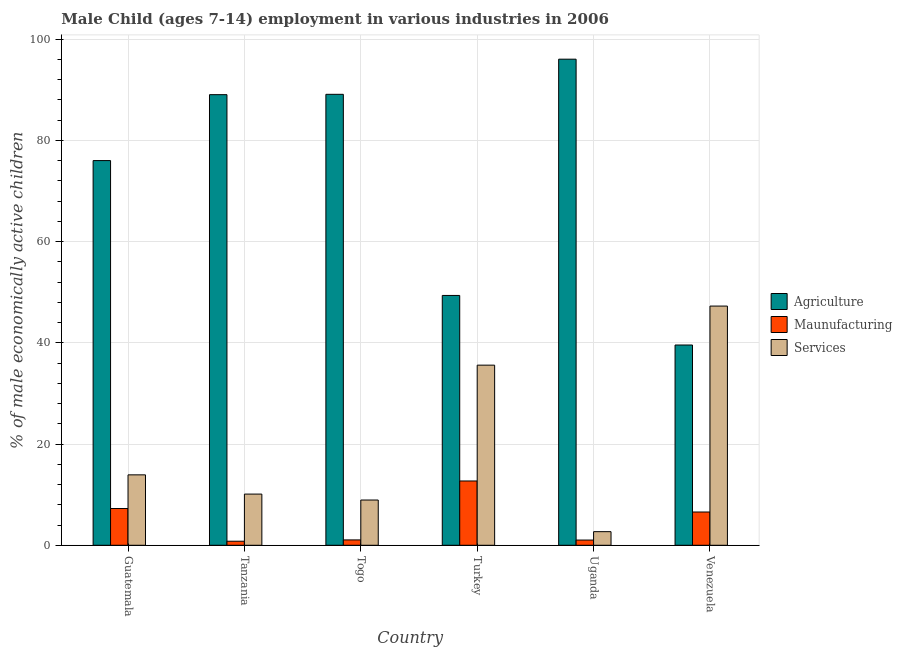Are the number of bars on each tick of the X-axis equal?
Offer a very short reply. Yes. How many bars are there on the 5th tick from the right?
Your response must be concise. 3. What is the label of the 3rd group of bars from the left?
Offer a terse response. Togo. In how many cases, is the number of bars for a given country not equal to the number of legend labels?
Provide a short and direct response. 0. What is the percentage of economically active children in services in Uganda?
Your answer should be very brief. 2.69. Across all countries, what is the maximum percentage of economically active children in manufacturing?
Make the answer very short. 12.7. Across all countries, what is the minimum percentage of economically active children in agriculture?
Offer a very short reply. 39.56. In which country was the percentage of economically active children in services maximum?
Provide a short and direct response. Venezuela. In which country was the percentage of economically active children in services minimum?
Give a very brief answer. Uganda. What is the total percentage of economically active children in manufacturing in the graph?
Provide a short and direct response. 29.42. What is the difference between the percentage of economically active children in manufacturing in Tanzania and that in Venezuela?
Provide a short and direct response. -5.77. What is the difference between the percentage of economically active children in services in Tanzania and the percentage of economically active children in agriculture in Turkey?
Give a very brief answer. -39.24. What is the average percentage of economically active children in agriculture per country?
Ensure brevity in your answer.  73.17. What is the difference between the percentage of economically active children in services and percentage of economically active children in agriculture in Turkey?
Give a very brief answer. -13.77. In how many countries, is the percentage of economically active children in services greater than 36 %?
Your answer should be very brief. 1. What is the ratio of the percentage of economically active children in agriculture in Tanzania to that in Uganda?
Ensure brevity in your answer.  0.93. Is the percentage of economically active children in services in Uganda less than that in Venezuela?
Offer a terse response. Yes. Is the difference between the percentage of economically active children in agriculture in Togo and Uganda greater than the difference between the percentage of economically active children in manufacturing in Togo and Uganda?
Your answer should be compact. No. What is the difference between the highest and the second highest percentage of economically active children in services?
Provide a short and direct response. 11.67. What is the difference between the highest and the lowest percentage of economically active children in agriculture?
Keep it short and to the point. 56.46. In how many countries, is the percentage of economically active children in services greater than the average percentage of economically active children in services taken over all countries?
Keep it short and to the point. 2. What does the 3rd bar from the left in Tanzania represents?
Offer a terse response. Services. What does the 1st bar from the right in Togo represents?
Keep it short and to the point. Services. Are all the bars in the graph horizontal?
Offer a very short reply. No. How many countries are there in the graph?
Keep it short and to the point. 6. What is the difference between two consecutive major ticks on the Y-axis?
Your answer should be very brief. 20. Does the graph contain any zero values?
Provide a short and direct response. No. What is the title of the graph?
Your answer should be compact. Male Child (ages 7-14) employment in various industries in 2006. Does "Ages 0-14" appear as one of the legend labels in the graph?
Offer a very short reply. No. What is the label or title of the Y-axis?
Your answer should be compact. % of male economically active children. What is the % of male economically active children in Agriculture in Guatemala?
Offer a very short reply. 75.99. What is the % of male economically active children of Maunufacturing in Guatemala?
Your answer should be very brief. 7.26. What is the % of male economically active children of Services in Guatemala?
Ensure brevity in your answer.  13.91. What is the % of male economically active children of Agriculture in Tanzania?
Keep it short and to the point. 89.01. What is the % of male economically active children in Maunufacturing in Tanzania?
Provide a short and direct response. 0.8. What is the % of male economically active children in Services in Tanzania?
Give a very brief answer. 10.11. What is the % of male economically active children in Agriculture in Togo?
Provide a short and direct response. 89.08. What is the % of male economically active children of Maunufacturing in Togo?
Offer a terse response. 1.06. What is the % of male economically active children in Services in Togo?
Your response must be concise. 8.94. What is the % of male economically active children of Agriculture in Turkey?
Your answer should be very brief. 49.35. What is the % of male economically active children in Maunufacturing in Turkey?
Offer a very short reply. 12.7. What is the % of male economically active children in Services in Turkey?
Your answer should be very brief. 35.58. What is the % of male economically active children in Agriculture in Uganda?
Provide a succinct answer. 96.02. What is the % of male economically active children in Services in Uganda?
Offer a terse response. 2.69. What is the % of male economically active children of Agriculture in Venezuela?
Offer a very short reply. 39.56. What is the % of male economically active children of Maunufacturing in Venezuela?
Make the answer very short. 6.57. What is the % of male economically active children of Services in Venezuela?
Your answer should be very brief. 47.25. Across all countries, what is the maximum % of male economically active children in Agriculture?
Offer a very short reply. 96.02. Across all countries, what is the maximum % of male economically active children of Services?
Keep it short and to the point. 47.25. Across all countries, what is the minimum % of male economically active children of Agriculture?
Offer a very short reply. 39.56. Across all countries, what is the minimum % of male economically active children in Services?
Offer a very short reply. 2.69. What is the total % of male economically active children in Agriculture in the graph?
Your answer should be very brief. 439.01. What is the total % of male economically active children of Maunufacturing in the graph?
Offer a terse response. 29.42. What is the total % of male economically active children in Services in the graph?
Offer a terse response. 118.48. What is the difference between the % of male economically active children in Agriculture in Guatemala and that in Tanzania?
Ensure brevity in your answer.  -13.02. What is the difference between the % of male economically active children of Maunufacturing in Guatemala and that in Tanzania?
Your answer should be compact. 6.46. What is the difference between the % of male economically active children of Services in Guatemala and that in Tanzania?
Your answer should be very brief. 3.8. What is the difference between the % of male economically active children of Agriculture in Guatemala and that in Togo?
Ensure brevity in your answer.  -13.09. What is the difference between the % of male economically active children in Maunufacturing in Guatemala and that in Togo?
Make the answer very short. 6.2. What is the difference between the % of male economically active children in Services in Guatemala and that in Togo?
Give a very brief answer. 4.97. What is the difference between the % of male economically active children of Agriculture in Guatemala and that in Turkey?
Keep it short and to the point. 26.64. What is the difference between the % of male economically active children of Maunufacturing in Guatemala and that in Turkey?
Make the answer very short. -5.44. What is the difference between the % of male economically active children in Services in Guatemala and that in Turkey?
Your answer should be compact. -21.67. What is the difference between the % of male economically active children of Agriculture in Guatemala and that in Uganda?
Your answer should be compact. -20.03. What is the difference between the % of male economically active children in Maunufacturing in Guatemala and that in Uganda?
Offer a very short reply. 6.23. What is the difference between the % of male economically active children of Services in Guatemala and that in Uganda?
Keep it short and to the point. 11.22. What is the difference between the % of male economically active children of Agriculture in Guatemala and that in Venezuela?
Offer a very short reply. 36.43. What is the difference between the % of male economically active children of Maunufacturing in Guatemala and that in Venezuela?
Provide a short and direct response. 0.69. What is the difference between the % of male economically active children in Services in Guatemala and that in Venezuela?
Make the answer very short. -33.34. What is the difference between the % of male economically active children of Agriculture in Tanzania and that in Togo?
Make the answer very short. -0.07. What is the difference between the % of male economically active children of Maunufacturing in Tanzania and that in Togo?
Your answer should be very brief. -0.26. What is the difference between the % of male economically active children in Services in Tanzania and that in Togo?
Make the answer very short. 1.17. What is the difference between the % of male economically active children in Agriculture in Tanzania and that in Turkey?
Offer a very short reply. 39.66. What is the difference between the % of male economically active children of Maunufacturing in Tanzania and that in Turkey?
Your response must be concise. -11.9. What is the difference between the % of male economically active children in Services in Tanzania and that in Turkey?
Offer a very short reply. -25.47. What is the difference between the % of male economically active children of Agriculture in Tanzania and that in Uganda?
Ensure brevity in your answer.  -7.01. What is the difference between the % of male economically active children of Maunufacturing in Tanzania and that in Uganda?
Provide a short and direct response. -0.23. What is the difference between the % of male economically active children of Services in Tanzania and that in Uganda?
Make the answer very short. 7.42. What is the difference between the % of male economically active children of Agriculture in Tanzania and that in Venezuela?
Offer a very short reply. 49.45. What is the difference between the % of male economically active children in Maunufacturing in Tanzania and that in Venezuela?
Offer a terse response. -5.77. What is the difference between the % of male economically active children of Services in Tanzania and that in Venezuela?
Offer a terse response. -37.14. What is the difference between the % of male economically active children in Agriculture in Togo and that in Turkey?
Your answer should be very brief. 39.73. What is the difference between the % of male economically active children of Maunufacturing in Togo and that in Turkey?
Provide a succinct answer. -11.64. What is the difference between the % of male economically active children of Services in Togo and that in Turkey?
Your answer should be very brief. -26.64. What is the difference between the % of male economically active children in Agriculture in Togo and that in Uganda?
Provide a succinct answer. -6.94. What is the difference between the % of male economically active children of Services in Togo and that in Uganda?
Your answer should be very brief. 6.25. What is the difference between the % of male economically active children in Agriculture in Togo and that in Venezuela?
Your answer should be compact. 49.52. What is the difference between the % of male economically active children in Maunufacturing in Togo and that in Venezuela?
Offer a terse response. -5.51. What is the difference between the % of male economically active children of Services in Togo and that in Venezuela?
Offer a terse response. -38.31. What is the difference between the % of male economically active children in Agriculture in Turkey and that in Uganda?
Your answer should be compact. -46.67. What is the difference between the % of male economically active children in Maunufacturing in Turkey and that in Uganda?
Give a very brief answer. 11.67. What is the difference between the % of male economically active children in Services in Turkey and that in Uganda?
Give a very brief answer. 32.89. What is the difference between the % of male economically active children in Agriculture in Turkey and that in Venezuela?
Ensure brevity in your answer.  9.79. What is the difference between the % of male economically active children of Maunufacturing in Turkey and that in Venezuela?
Provide a succinct answer. 6.13. What is the difference between the % of male economically active children in Services in Turkey and that in Venezuela?
Ensure brevity in your answer.  -11.67. What is the difference between the % of male economically active children of Agriculture in Uganda and that in Venezuela?
Provide a short and direct response. 56.46. What is the difference between the % of male economically active children in Maunufacturing in Uganda and that in Venezuela?
Offer a terse response. -5.54. What is the difference between the % of male economically active children in Services in Uganda and that in Venezuela?
Keep it short and to the point. -44.56. What is the difference between the % of male economically active children of Agriculture in Guatemala and the % of male economically active children of Maunufacturing in Tanzania?
Give a very brief answer. 75.19. What is the difference between the % of male economically active children in Agriculture in Guatemala and the % of male economically active children in Services in Tanzania?
Make the answer very short. 65.88. What is the difference between the % of male economically active children in Maunufacturing in Guatemala and the % of male economically active children in Services in Tanzania?
Your response must be concise. -2.85. What is the difference between the % of male economically active children of Agriculture in Guatemala and the % of male economically active children of Maunufacturing in Togo?
Ensure brevity in your answer.  74.93. What is the difference between the % of male economically active children of Agriculture in Guatemala and the % of male economically active children of Services in Togo?
Provide a short and direct response. 67.05. What is the difference between the % of male economically active children in Maunufacturing in Guatemala and the % of male economically active children in Services in Togo?
Provide a short and direct response. -1.68. What is the difference between the % of male economically active children of Agriculture in Guatemala and the % of male economically active children of Maunufacturing in Turkey?
Offer a terse response. 63.29. What is the difference between the % of male economically active children of Agriculture in Guatemala and the % of male economically active children of Services in Turkey?
Provide a short and direct response. 40.41. What is the difference between the % of male economically active children in Maunufacturing in Guatemala and the % of male economically active children in Services in Turkey?
Your response must be concise. -28.32. What is the difference between the % of male economically active children in Agriculture in Guatemala and the % of male economically active children in Maunufacturing in Uganda?
Provide a short and direct response. 74.96. What is the difference between the % of male economically active children of Agriculture in Guatemala and the % of male economically active children of Services in Uganda?
Offer a very short reply. 73.3. What is the difference between the % of male economically active children in Maunufacturing in Guatemala and the % of male economically active children in Services in Uganda?
Give a very brief answer. 4.57. What is the difference between the % of male economically active children of Agriculture in Guatemala and the % of male economically active children of Maunufacturing in Venezuela?
Provide a short and direct response. 69.42. What is the difference between the % of male economically active children of Agriculture in Guatemala and the % of male economically active children of Services in Venezuela?
Your response must be concise. 28.74. What is the difference between the % of male economically active children of Maunufacturing in Guatemala and the % of male economically active children of Services in Venezuela?
Keep it short and to the point. -39.99. What is the difference between the % of male economically active children in Agriculture in Tanzania and the % of male economically active children in Maunufacturing in Togo?
Make the answer very short. 87.95. What is the difference between the % of male economically active children in Agriculture in Tanzania and the % of male economically active children in Services in Togo?
Provide a short and direct response. 80.07. What is the difference between the % of male economically active children of Maunufacturing in Tanzania and the % of male economically active children of Services in Togo?
Your answer should be compact. -8.14. What is the difference between the % of male economically active children of Agriculture in Tanzania and the % of male economically active children of Maunufacturing in Turkey?
Ensure brevity in your answer.  76.31. What is the difference between the % of male economically active children in Agriculture in Tanzania and the % of male economically active children in Services in Turkey?
Give a very brief answer. 53.43. What is the difference between the % of male economically active children in Maunufacturing in Tanzania and the % of male economically active children in Services in Turkey?
Keep it short and to the point. -34.78. What is the difference between the % of male economically active children of Agriculture in Tanzania and the % of male economically active children of Maunufacturing in Uganda?
Offer a very short reply. 87.98. What is the difference between the % of male economically active children in Agriculture in Tanzania and the % of male economically active children in Services in Uganda?
Give a very brief answer. 86.32. What is the difference between the % of male economically active children of Maunufacturing in Tanzania and the % of male economically active children of Services in Uganda?
Offer a very short reply. -1.89. What is the difference between the % of male economically active children of Agriculture in Tanzania and the % of male economically active children of Maunufacturing in Venezuela?
Give a very brief answer. 82.44. What is the difference between the % of male economically active children of Agriculture in Tanzania and the % of male economically active children of Services in Venezuela?
Offer a terse response. 41.76. What is the difference between the % of male economically active children of Maunufacturing in Tanzania and the % of male economically active children of Services in Venezuela?
Give a very brief answer. -46.45. What is the difference between the % of male economically active children of Agriculture in Togo and the % of male economically active children of Maunufacturing in Turkey?
Your response must be concise. 76.38. What is the difference between the % of male economically active children of Agriculture in Togo and the % of male economically active children of Services in Turkey?
Offer a very short reply. 53.5. What is the difference between the % of male economically active children of Maunufacturing in Togo and the % of male economically active children of Services in Turkey?
Make the answer very short. -34.52. What is the difference between the % of male economically active children in Agriculture in Togo and the % of male economically active children in Maunufacturing in Uganda?
Ensure brevity in your answer.  88.05. What is the difference between the % of male economically active children of Agriculture in Togo and the % of male economically active children of Services in Uganda?
Your response must be concise. 86.39. What is the difference between the % of male economically active children in Maunufacturing in Togo and the % of male economically active children in Services in Uganda?
Your answer should be very brief. -1.63. What is the difference between the % of male economically active children in Agriculture in Togo and the % of male economically active children in Maunufacturing in Venezuela?
Offer a very short reply. 82.51. What is the difference between the % of male economically active children in Agriculture in Togo and the % of male economically active children in Services in Venezuela?
Offer a terse response. 41.83. What is the difference between the % of male economically active children in Maunufacturing in Togo and the % of male economically active children in Services in Venezuela?
Give a very brief answer. -46.19. What is the difference between the % of male economically active children of Agriculture in Turkey and the % of male economically active children of Maunufacturing in Uganda?
Keep it short and to the point. 48.32. What is the difference between the % of male economically active children in Agriculture in Turkey and the % of male economically active children in Services in Uganda?
Make the answer very short. 46.66. What is the difference between the % of male economically active children in Maunufacturing in Turkey and the % of male economically active children in Services in Uganda?
Ensure brevity in your answer.  10.01. What is the difference between the % of male economically active children in Agriculture in Turkey and the % of male economically active children in Maunufacturing in Venezuela?
Make the answer very short. 42.78. What is the difference between the % of male economically active children in Agriculture in Turkey and the % of male economically active children in Services in Venezuela?
Offer a very short reply. 2.1. What is the difference between the % of male economically active children in Maunufacturing in Turkey and the % of male economically active children in Services in Venezuela?
Offer a terse response. -34.55. What is the difference between the % of male economically active children of Agriculture in Uganda and the % of male economically active children of Maunufacturing in Venezuela?
Ensure brevity in your answer.  89.45. What is the difference between the % of male economically active children of Agriculture in Uganda and the % of male economically active children of Services in Venezuela?
Ensure brevity in your answer.  48.77. What is the difference between the % of male economically active children in Maunufacturing in Uganda and the % of male economically active children in Services in Venezuela?
Your answer should be compact. -46.22. What is the average % of male economically active children in Agriculture per country?
Offer a very short reply. 73.17. What is the average % of male economically active children of Maunufacturing per country?
Your answer should be very brief. 4.9. What is the average % of male economically active children in Services per country?
Make the answer very short. 19.75. What is the difference between the % of male economically active children of Agriculture and % of male economically active children of Maunufacturing in Guatemala?
Ensure brevity in your answer.  68.73. What is the difference between the % of male economically active children of Agriculture and % of male economically active children of Services in Guatemala?
Give a very brief answer. 62.08. What is the difference between the % of male economically active children of Maunufacturing and % of male economically active children of Services in Guatemala?
Provide a succinct answer. -6.65. What is the difference between the % of male economically active children of Agriculture and % of male economically active children of Maunufacturing in Tanzania?
Ensure brevity in your answer.  88.21. What is the difference between the % of male economically active children in Agriculture and % of male economically active children in Services in Tanzania?
Keep it short and to the point. 78.9. What is the difference between the % of male economically active children in Maunufacturing and % of male economically active children in Services in Tanzania?
Give a very brief answer. -9.31. What is the difference between the % of male economically active children in Agriculture and % of male economically active children in Maunufacturing in Togo?
Ensure brevity in your answer.  88.02. What is the difference between the % of male economically active children of Agriculture and % of male economically active children of Services in Togo?
Provide a succinct answer. 80.14. What is the difference between the % of male economically active children of Maunufacturing and % of male economically active children of Services in Togo?
Keep it short and to the point. -7.88. What is the difference between the % of male economically active children in Agriculture and % of male economically active children in Maunufacturing in Turkey?
Ensure brevity in your answer.  36.65. What is the difference between the % of male economically active children of Agriculture and % of male economically active children of Services in Turkey?
Provide a short and direct response. 13.77. What is the difference between the % of male economically active children of Maunufacturing and % of male economically active children of Services in Turkey?
Make the answer very short. -22.88. What is the difference between the % of male economically active children of Agriculture and % of male economically active children of Maunufacturing in Uganda?
Your answer should be very brief. 94.99. What is the difference between the % of male economically active children of Agriculture and % of male economically active children of Services in Uganda?
Offer a very short reply. 93.33. What is the difference between the % of male economically active children of Maunufacturing and % of male economically active children of Services in Uganda?
Give a very brief answer. -1.66. What is the difference between the % of male economically active children in Agriculture and % of male economically active children in Maunufacturing in Venezuela?
Keep it short and to the point. 32.99. What is the difference between the % of male economically active children in Agriculture and % of male economically active children in Services in Venezuela?
Offer a terse response. -7.69. What is the difference between the % of male economically active children of Maunufacturing and % of male economically active children of Services in Venezuela?
Ensure brevity in your answer.  -40.68. What is the ratio of the % of male economically active children in Agriculture in Guatemala to that in Tanzania?
Provide a succinct answer. 0.85. What is the ratio of the % of male economically active children in Maunufacturing in Guatemala to that in Tanzania?
Your response must be concise. 9.07. What is the ratio of the % of male economically active children of Services in Guatemala to that in Tanzania?
Ensure brevity in your answer.  1.38. What is the ratio of the % of male economically active children of Agriculture in Guatemala to that in Togo?
Give a very brief answer. 0.85. What is the ratio of the % of male economically active children of Maunufacturing in Guatemala to that in Togo?
Offer a terse response. 6.85. What is the ratio of the % of male economically active children of Services in Guatemala to that in Togo?
Your response must be concise. 1.56. What is the ratio of the % of male economically active children in Agriculture in Guatemala to that in Turkey?
Give a very brief answer. 1.54. What is the ratio of the % of male economically active children in Maunufacturing in Guatemala to that in Turkey?
Ensure brevity in your answer.  0.57. What is the ratio of the % of male economically active children of Services in Guatemala to that in Turkey?
Your answer should be compact. 0.39. What is the ratio of the % of male economically active children in Agriculture in Guatemala to that in Uganda?
Your response must be concise. 0.79. What is the ratio of the % of male economically active children in Maunufacturing in Guatemala to that in Uganda?
Give a very brief answer. 7.05. What is the ratio of the % of male economically active children of Services in Guatemala to that in Uganda?
Your response must be concise. 5.17. What is the ratio of the % of male economically active children of Agriculture in Guatemala to that in Venezuela?
Offer a terse response. 1.92. What is the ratio of the % of male economically active children of Maunufacturing in Guatemala to that in Venezuela?
Give a very brief answer. 1.1. What is the ratio of the % of male economically active children in Services in Guatemala to that in Venezuela?
Keep it short and to the point. 0.29. What is the ratio of the % of male economically active children of Agriculture in Tanzania to that in Togo?
Provide a short and direct response. 1. What is the ratio of the % of male economically active children in Maunufacturing in Tanzania to that in Togo?
Your answer should be very brief. 0.75. What is the ratio of the % of male economically active children in Services in Tanzania to that in Togo?
Your response must be concise. 1.13. What is the ratio of the % of male economically active children in Agriculture in Tanzania to that in Turkey?
Your response must be concise. 1.8. What is the ratio of the % of male economically active children of Maunufacturing in Tanzania to that in Turkey?
Keep it short and to the point. 0.06. What is the ratio of the % of male economically active children of Services in Tanzania to that in Turkey?
Offer a very short reply. 0.28. What is the ratio of the % of male economically active children of Agriculture in Tanzania to that in Uganda?
Your answer should be compact. 0.93. What is the ratio of the % of male economically active children in Maunufacturing in Tanzania to that in Uganda?
Provide a short and direct response. 0.78. What is the ratio of the % of male economically active children in Services in Tanzania to that in Uganda?
Your response must be concise. 3.76. What is the ratio of the % of male economically active children in Agriculture in Tanzania to that in Venezuela?
Your answer should be very brief. 2.25. What is the ratio of the % of male economically active children of Maunufacturing in Tanzania to that in Venezuela?
Offer a very short reply. 0.12. What is the ratio of the % of male economically active children of Services in Tanzania to that in Venezuela?
Your answer should be very brief. 0.21. What is the ratio of the % of male economically active children of Agriculture in Togo to that in Turkey?
Provide a short and direct response. 1.81. What is the ratio of the % of male economically active children in Maunufacturing in Togo to that in Turkey?
Make the answer very short. 0.08. What is the ratio of the % of male economically active children in Services in Togo to that in Turkey?
Make the answer very short. 0.25. What is the ratio of the % of male economically active children in Agriculture in Togo to that in Uganda?
Offer a very short reply. 0.93. What is the ratio of the % of male economically active children in Maunufacturing in Togo to that in Uganda?
Your answer should be compact. 1.03. What is the ratio of the % of male economically active children of Services in Togo to that in Uganda?
Provide a succinct answer. 3.32. What is the ratio of the % of male economically active children of Agriculture in Togo to that in Venezuela?
Give a very brief answer. 2.25. What is the ratio of the % of male economically active children in Maunufacturing in Togo to that in Venezuela?
Your answer should be very brief. 0.16. What is the ratio of the % of male economically active children in Services in Togo to that in Venezuela?
Your response must be concise. 0.19. What is the ratio of the % of male economically active children of Agriculture in Turkey to that in Uganda?
Your answer should be very brief. 0.51. What is the ratio of the % of male economically active children in Maunufacturing in Turkey to that in Uganda?
Make the answer very short. 12.33. What is the ratio of the % of male economically active children of Services in Turkey to that in Uganda?
Your response must be concise. 13.23. What is the ratio of the % of male economically active children in Agriculture in Turkey to that in Venezuela?
Ensure brevity in your answer.  1.25. What is the ratio of the % of male economically active children in Maunufacturing in Turkey to that in Venezuela?
Your answer should be very brief. 1.93. What is the ratio of the % of male economically active children in Services in Turkey to that in Venezuela?
Offer a very short reply. 0.75. What is the ratio of the % of male economically active children in Agriculture in Uganda to that in Venezuela?
Your answer should be compact. 2.43. What is the ratio of the % of male economically active children in Maunufacturing in Uganda to that in Venezuela?
Make the answer very short. 0.16. What is the ratio of the % of male economically active children in Services in Uganda to that in Venezuela?
Your response must be concise. 0.06. What is the difference between the highest and the second highest % of male economically active children in Agriculture?
Offer a very short reply. 6.94. What is the difference between the highest and the second highest % of male economically active children of Maunufacturing?
Offer a terse response. 5.44. What is the difference between the highest and the second highest % of male economically active children of Services?
Your answer should be compact. 11.67. What is the difference between the highest and the lowest % of male economically active children of Agriculture?
Offer a terse response. 56.46. What is the difference between the highest and the lowest % of male economically active children of Maunufacturing?
Keep it short and to the point. 11.9. What is the difference between the highest and the lowest % of male economically active children of Services?
Offer a terse response. 44.56. 